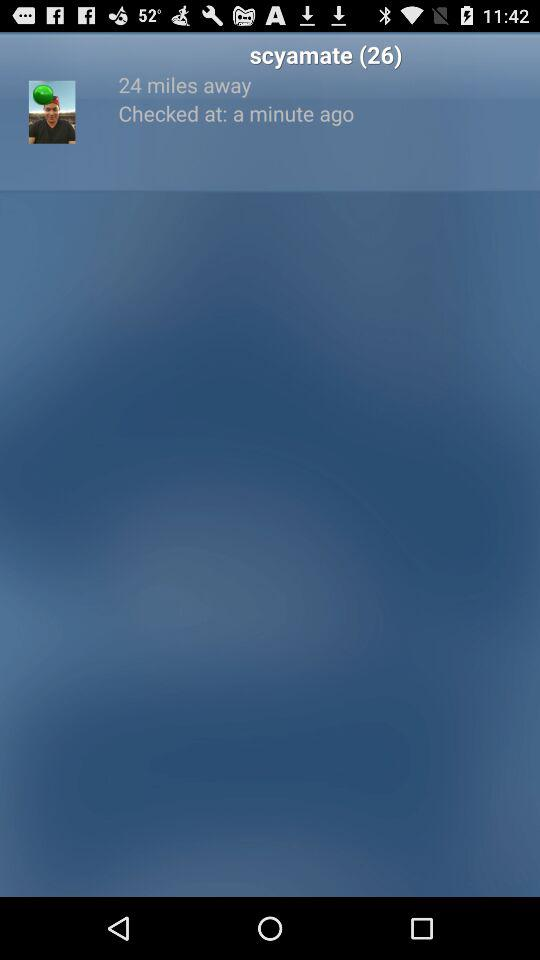What is the age of Scyamate? Scyamate is 26 years old. 